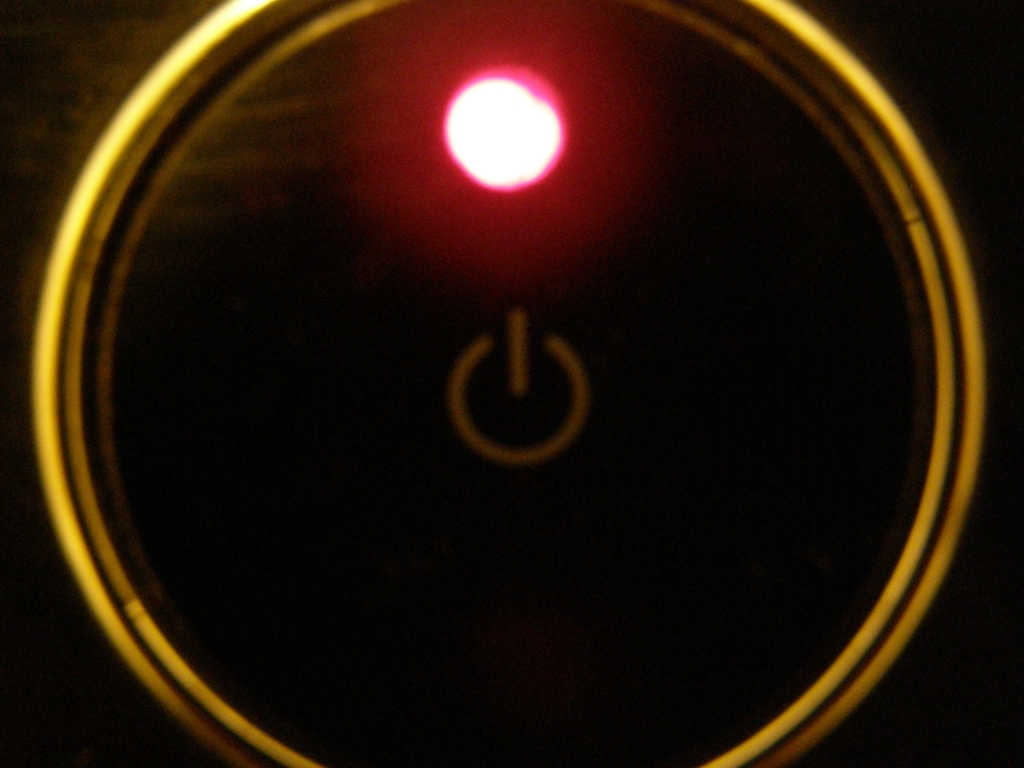Is the background sharp and detailed?
A. No
B. Yes
Answer with the option's letter from the given choices directly.
 A. 